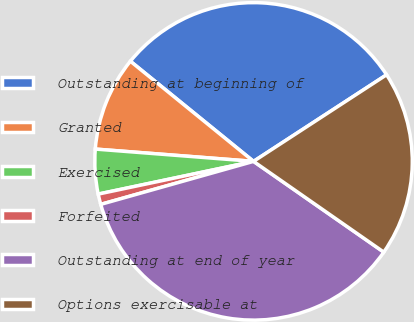Convert chart to OTSL. <chart><loc_0><loc_0><loc_500><loc_500><pie_chart><fcel>Outstanding at beginning of<fcel>Granted<fcel>Exercised<fcel>Forfeited<fcel>Outstanding at end of year<fcel>Options exercisable at<nl><fcel>29.95%<fcel>9.63%<fcel>4.54%<fcel>1.06%<fcel>35.95%<fcel>18.87%<nl></chart> 